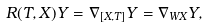<formula> <loc_0><loc_0><loc_500><loc_500>R ( T , X ) Y = \nabla _ { [ X , T ] } Y = \nabla _ { W X } Y ,</formula> 